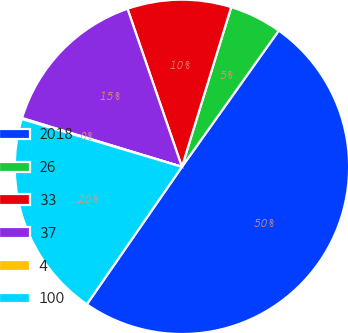<chart> <loc_0><loc_0><loc_500><loc_500><pie_chart><fcel>2018<fcel>26<fcel>33<fcel>37<fcel>4<fcel>100<nl><fcel>49.8%<fcel>5.07%<fcel>10.04%<fcel>15.01%<fcel>0.1%<fcel>19.98%<nl></chart> 